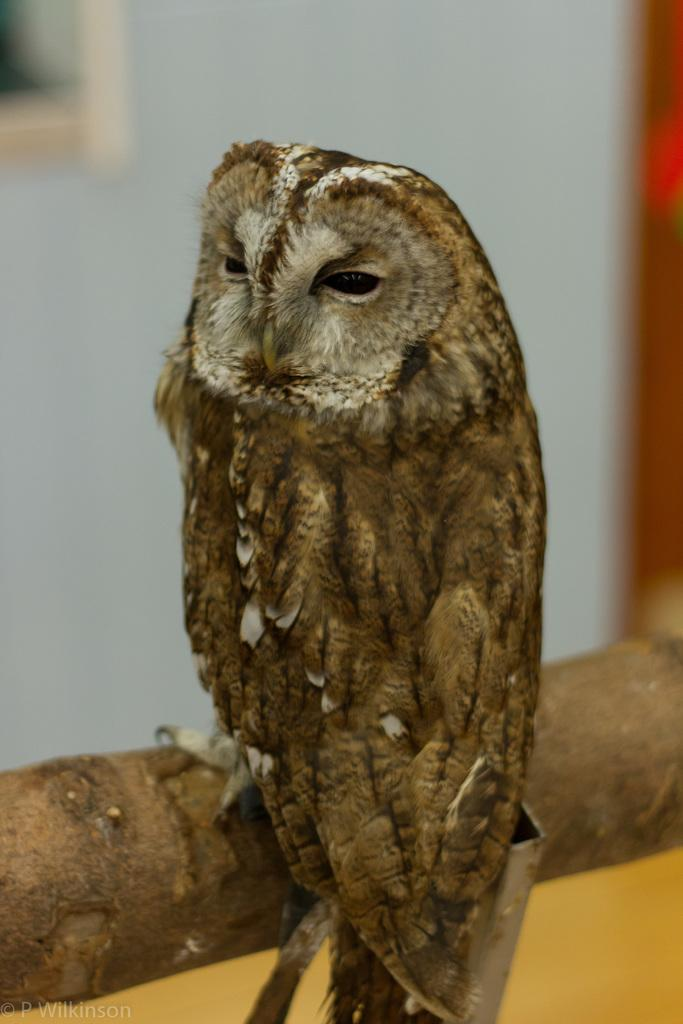What animal is present in the image? There is an owl in the image. What is the owl sitting on? The owl is on a wooden object. Can you describe the background of the image? The background of the image is blurred. What type of copper material can be seen in the image? There is no copper material present in the image. What learning activity is taking place in the image? There is no learning activity depicted in the image; it features an owl on a wooden object with a blurred background. 